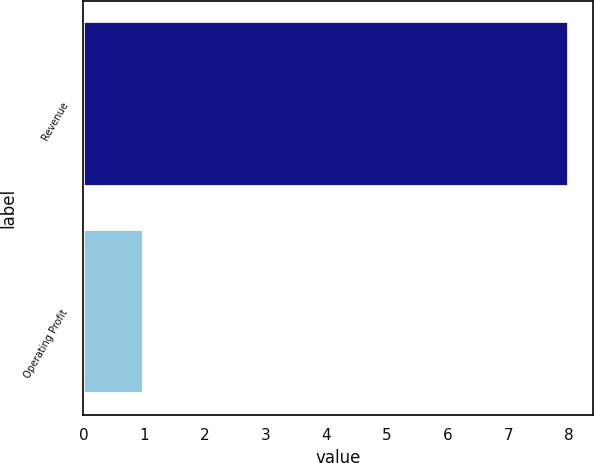Convert chart. <chart><loc_0><loc_0><loc_500><loc_500><bar_chart><fcel>Revenue<fcel>Operating Profit<nl><fcel>8<fcel>1<nl></chart> 